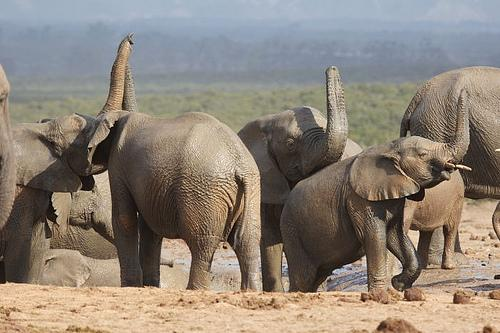What part of the body are the elephants holding up? Please explain your reasoning. trunks. Their tails and ears are down. elephants do not have arms. 